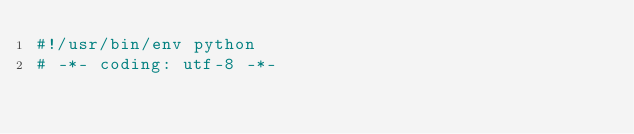Convert code to text. <code><loc_0><loc_0><loc_500><loc_500><_Python_>#!/usr/bin/env python
# -*- coding: utf-8 -*-</code> 